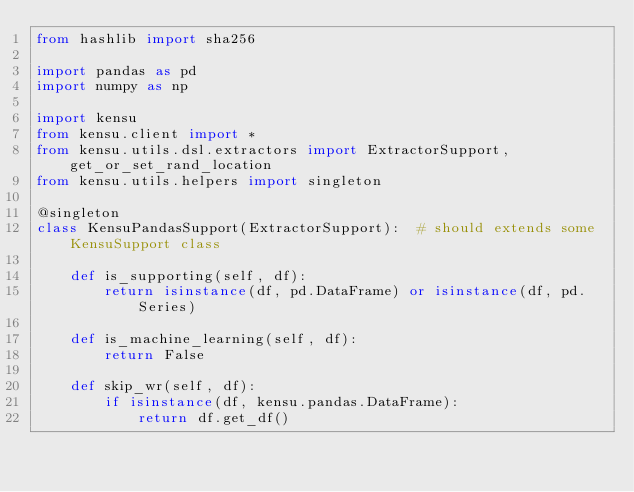<code> <loc_0><loc_0><loc_500><loc_500><_Python_>from hashlib import sha256

import pandas as pd
import numpy as np

import kensu
from kensu.client import *
from kensu.utils.dsl.extractors import ExtractorSupport, get_or_set_rand_location
from kensu.utils.helpers import singleton

@singleton
class KensuPandasSupport(ExtractorSupport):  # should extends some KensuSupport class

    def is_supporting(self, df):
        return isinstance(df, pd.DataFrame) or isinstance(df, pd.Series)

    def is_machine_learning(self, df):
        return False

    def skip_wr(self, df):
        if isinstance(df, kensu.pandas.DataFrame):
            return df.get_df()</code> 